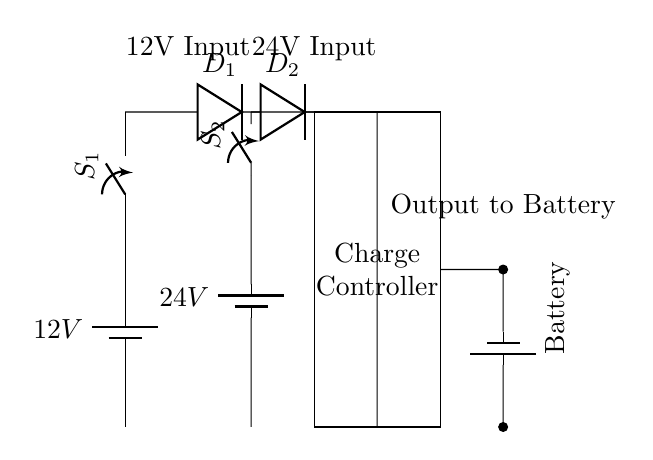What voltage sources are present in the circuit? The circuit includes two battery sources: one labeled 12V and another labeled 24V. These indicate the voltages supplied by each battery.
Answer: 12V and 24V What is the purpose of the diodes in this circuit? The diodes are used to prevent backflow of current between the 12V and 24V systems, allowing only the current from the connected voltage source to flow into the charge controller.
Answer: Prevent backflow How many switches are there in the circuit? The circuit has two switches, labeled S1 and S2. Each switch is connected to a different voltage source, allowing control over their operation.
Answer: Two What component does the output connect to? The output from the charge controller connects to a battery, as indicated in the circuit diagram. This indicates that the charge controller is managing the charging of this battery.
Answer: Battery How does the charge controller determine which voltage to use for charging? The charge controller combines the inputs from both the 12V and 24V batteries and regulates the voltage sent to the output. The presence of both switches allows for selective input based on system requirement.
Answer: By regulating inputs What is the role of the charge controller in the circuit? The charge controller manages the charge coming from either battery, ensuring that the correct voltage and current are directed to the output battery without overcharging it. This is crucial for battery health and longevity.
Answer: Manage charging 